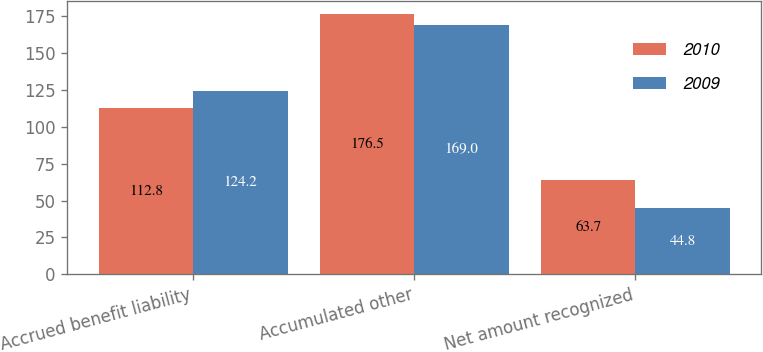Convert chart to OTSL. <chart><loc_0><loc_0><loc_500><loc_500><stacked_bar_chart><ecel><fcel>Accrued benefit liability<fcel>Accumulated other<fcel>Net amount recognized<nl><fcel>2010<fcel>112.8<fcel>176.5<fcel>63.7<nl><fcel>2009<fcel>124.2<fcel>169<fcel>44.8<nl></chart> 